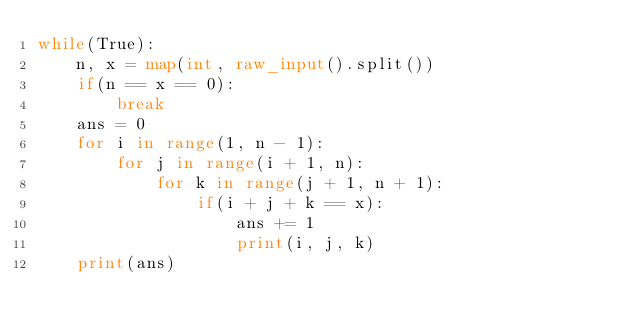Convert code to text. <code><loc_0><loc_0><loc_500><loc_500><_Python_>while(True):
    n, x = map(int, raw_input().split())
    if(n == x == 0):
        break
    ans = 0
    for i in range(1, n - 1):
        for j in range(i + 1, n):
            for k in range(j + 1, n + 1):
                if(i + j + k == x):
                    ans += 1
                    print(i, j, k)
    print(ans)</code> 